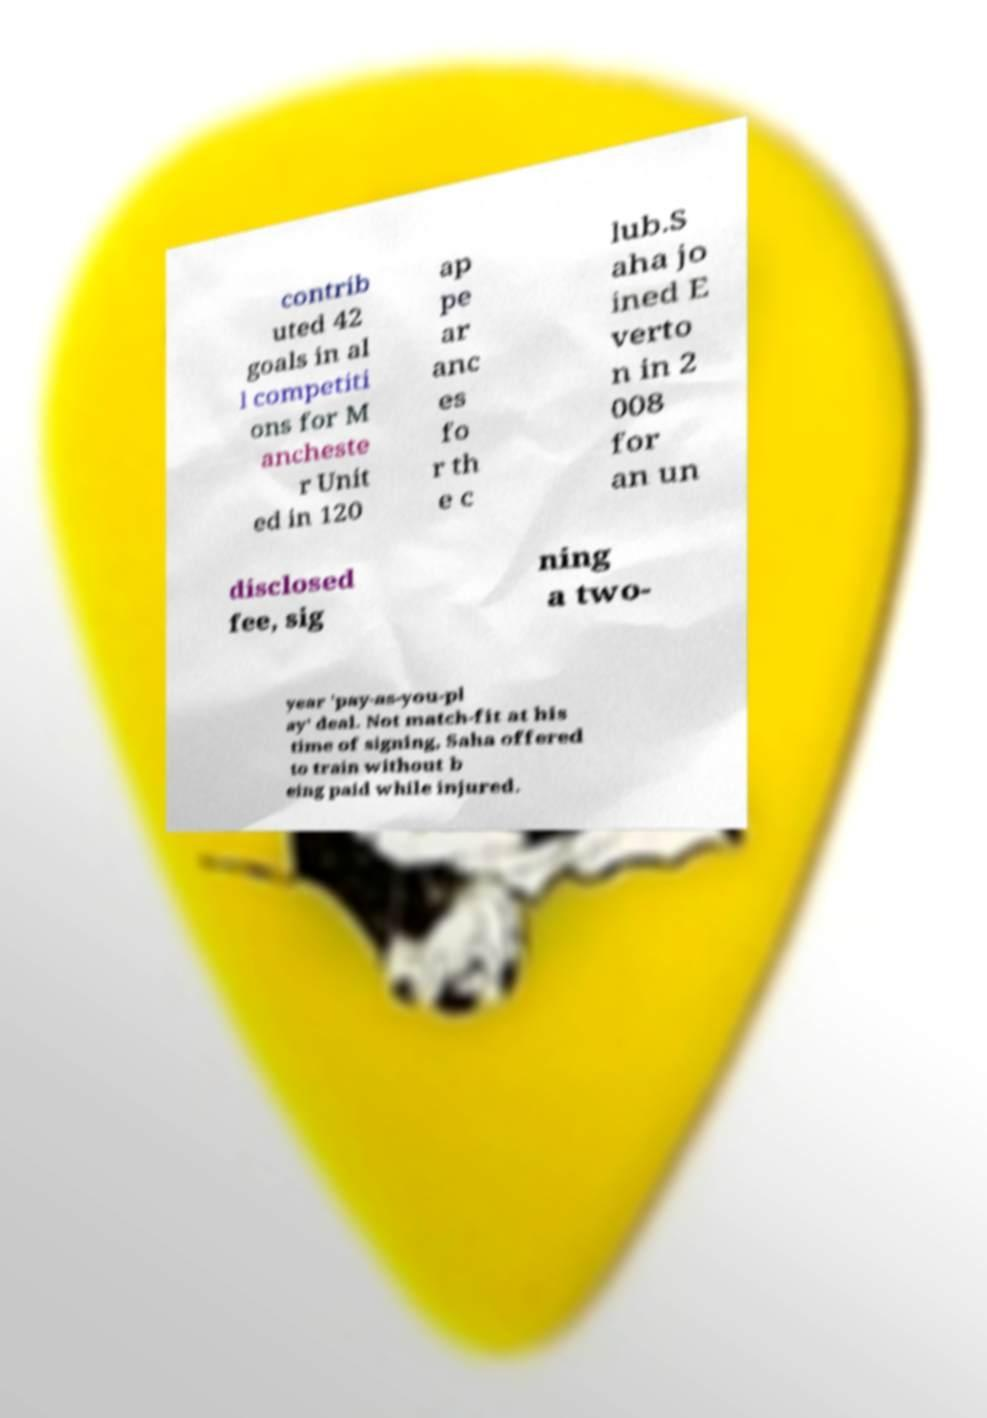What messages or text are displayed in this image? I need them in a readable, typed format. contrib uted 42 goals in al l competiti ons for M ancheste r Unit ed in 120 ap pe ar anc es fo r th e c lub.S aha jo ined E verto n in 2 008 for an un disclosed fee, sig ning a two- year 'pay-as-you-pl ay' deal. Not match-fit at his time of signing, Saha offered to train without b eing paid while injured. 